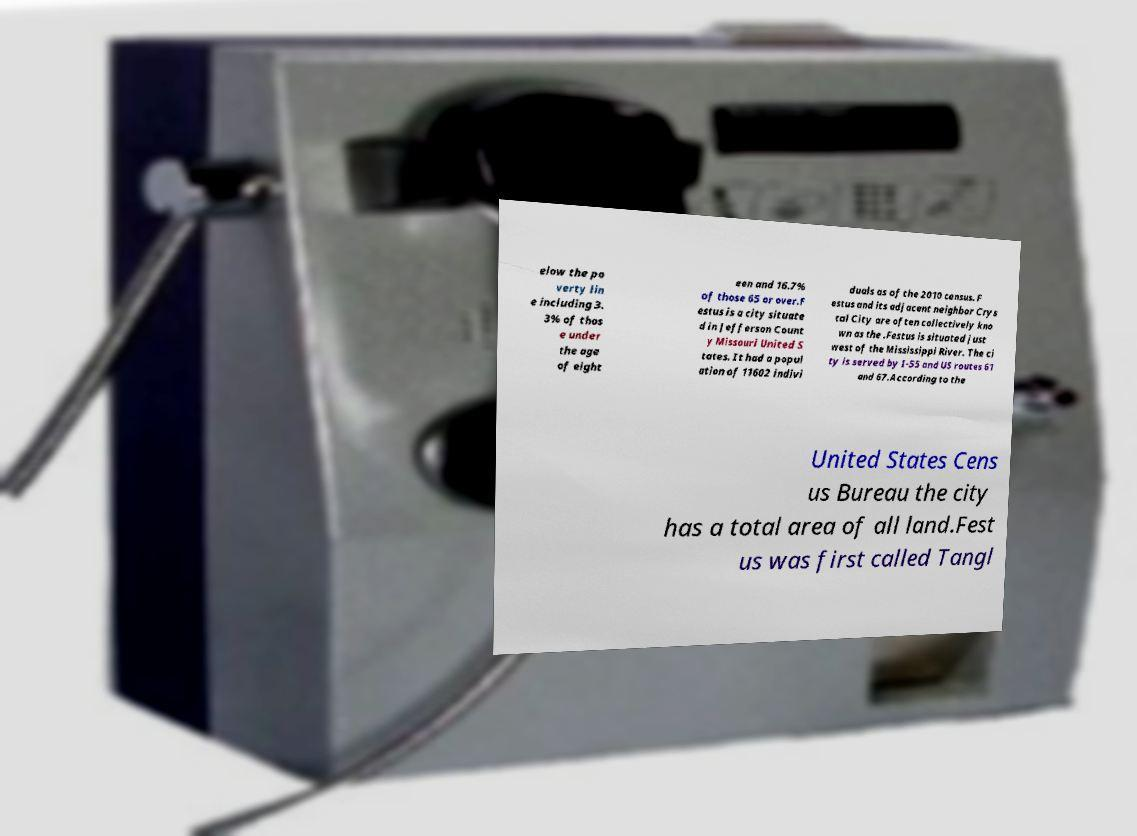Can you read and provide the text displayed in the image?This photo seems to have some interesting text. Can you extract and type it out for me? elow the po verty lin e including 3. 3% of thos e under the age of eight een and 16.7% of those 65 or over.F estus is a city situate d in Jefferson Count y Missouri United S tates. It had a popul ation of 11602 indivi duals as of the 2010 census. F estus and its adjacent neighbor Crys tal City are often collectively kno wn as the .Festus is situated just west of the Mississippi River. The ci ty is served by I-55 and US routes 61 and 67.According to the United States Cens us Bureau the city has a total area of all land.Fest us was first called Tangl 